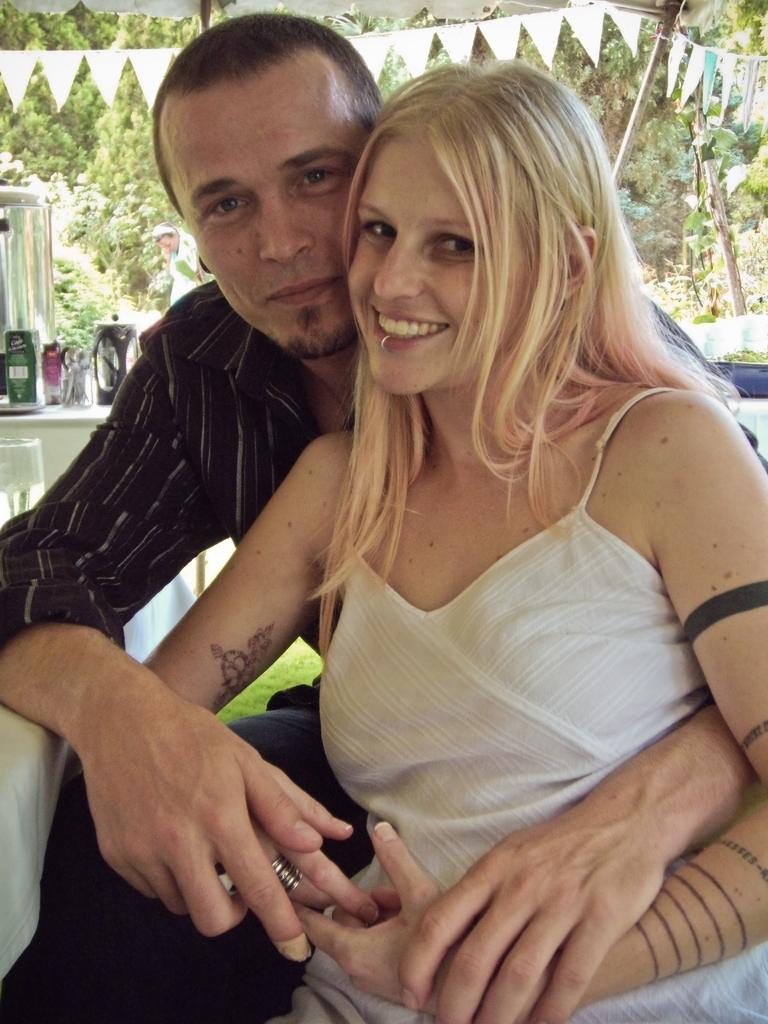Who is present in the image? There is a couple in the image. What is the emotional state of the couple? Both individuals in the couple are smiling. What can be seen in the background of the image? There are trees in the background of the image. How many cherries are on the board that the couple is wearing in the image? There is no board or cherries present in the image. The couple is not wearing any suits either. 